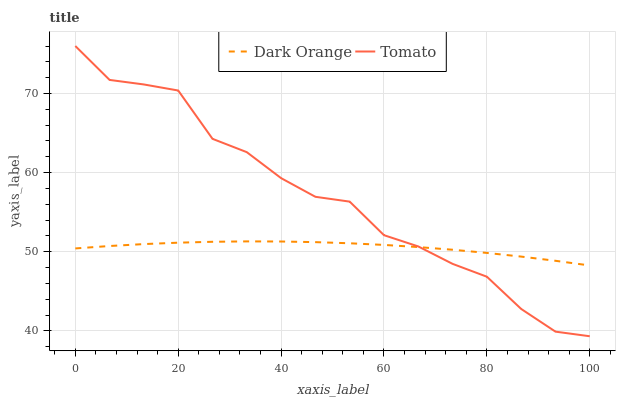Does Dark Orange have the minimum area under the curve?
Answer yes or no. Yes. Does Tomato have the maximum area under the curve?
Answer yes or no. Yes. Does Dark Orange have the maximum area under the curve?
Answer yes or no. No. Is Dark Orange the smoothest?
Answer yes or no. Yes. Is Tomato the roughest?
Answer yes or no. Yes. Is Dark Orange the roughest?
Answer yes or no. No. Does Tomato have the lowest value?
Answer yes or no. Yes. Does Dark Orange have the lowest value?
Answer yes or no. No. Does Tomato have the highest value?
Answer yes or no. Yes. Does Dark Orange have the highest value?
Answer yes or no. No. Does Dark Orange intersect Tomato?
Answer yes or no. Yes. Is Dark Orange less than Tomato?
Answer yes or no. No. Is Dark Orange greater than Tomato?
Answer yes or no. No. 